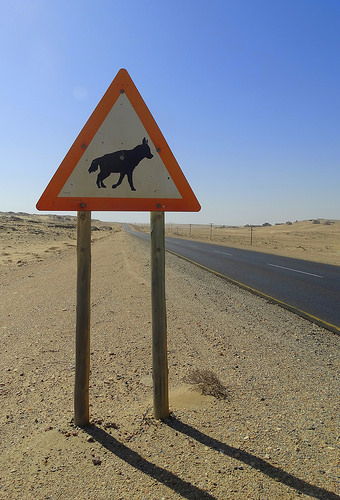<image>
Is there a shadow under the sign? Yes. The shadow is positioned underneath the sign, with the sign above it in the vertical space. Is the wolf in front of the board? No. The wolf is not in front of the board. The spatial positioning shows a different relationship between these objects. 